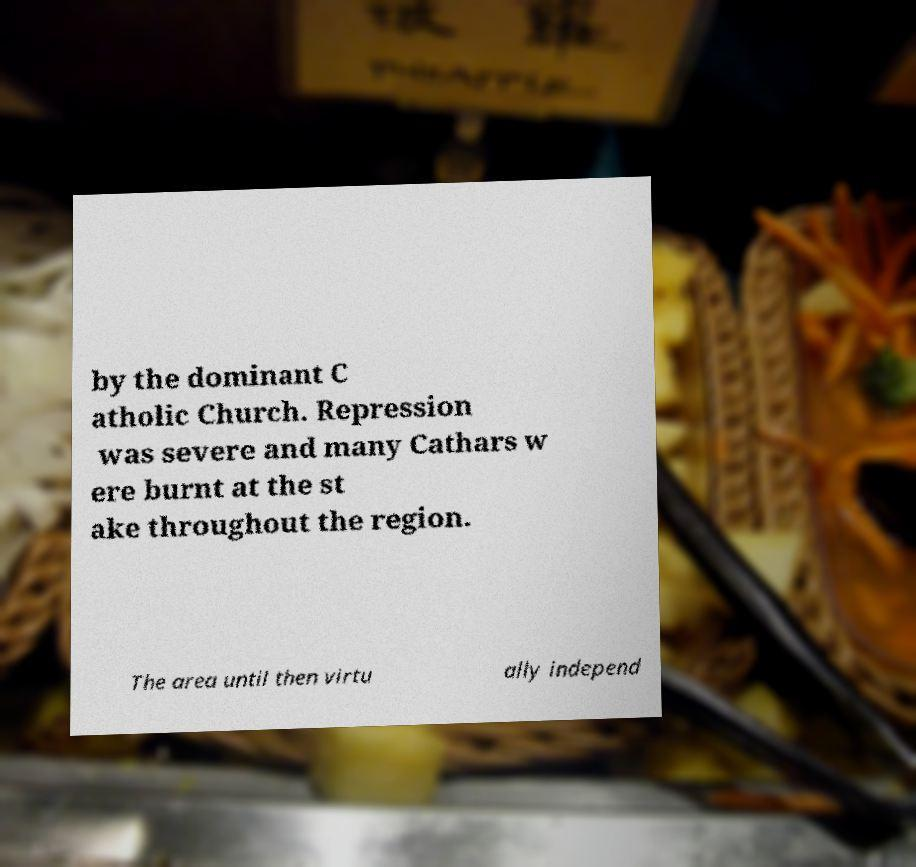What messages or text are displayed in this image? I need them in a readable, typed format. by the dominant C atholic Church. Repression was severe and many Cathars w ere burnt at the st ake throughout the region. The area until then virtu ally independ 